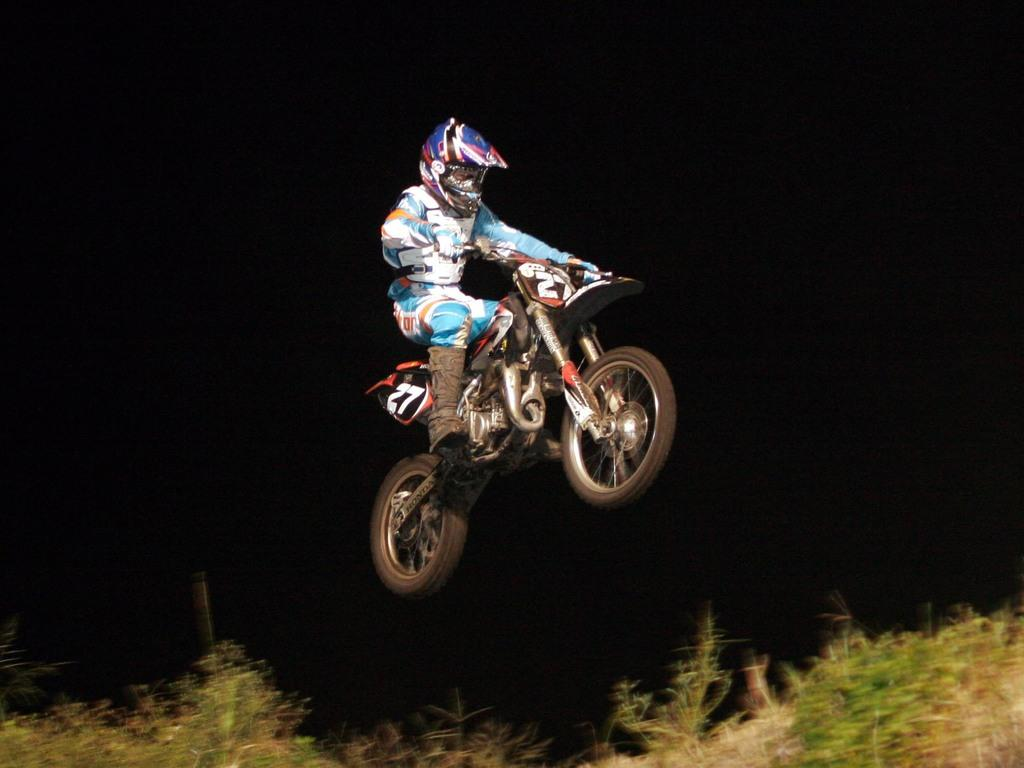What is the main subject of the image? The main subject of the image is a person riding a bike. What is unique about the bike in the image? The bike is in the air. How would you describe the background of the image? The background of the image is dark. What type of vegetation is present at the bottom of the image? There is a group of plants at the bottom of the image. What type of farm animals can be seen grazing in the image? There are no farm animals present in the image. What type of straw is used to decorate the bushes in the image? There are no bushes or straw present in the image. 